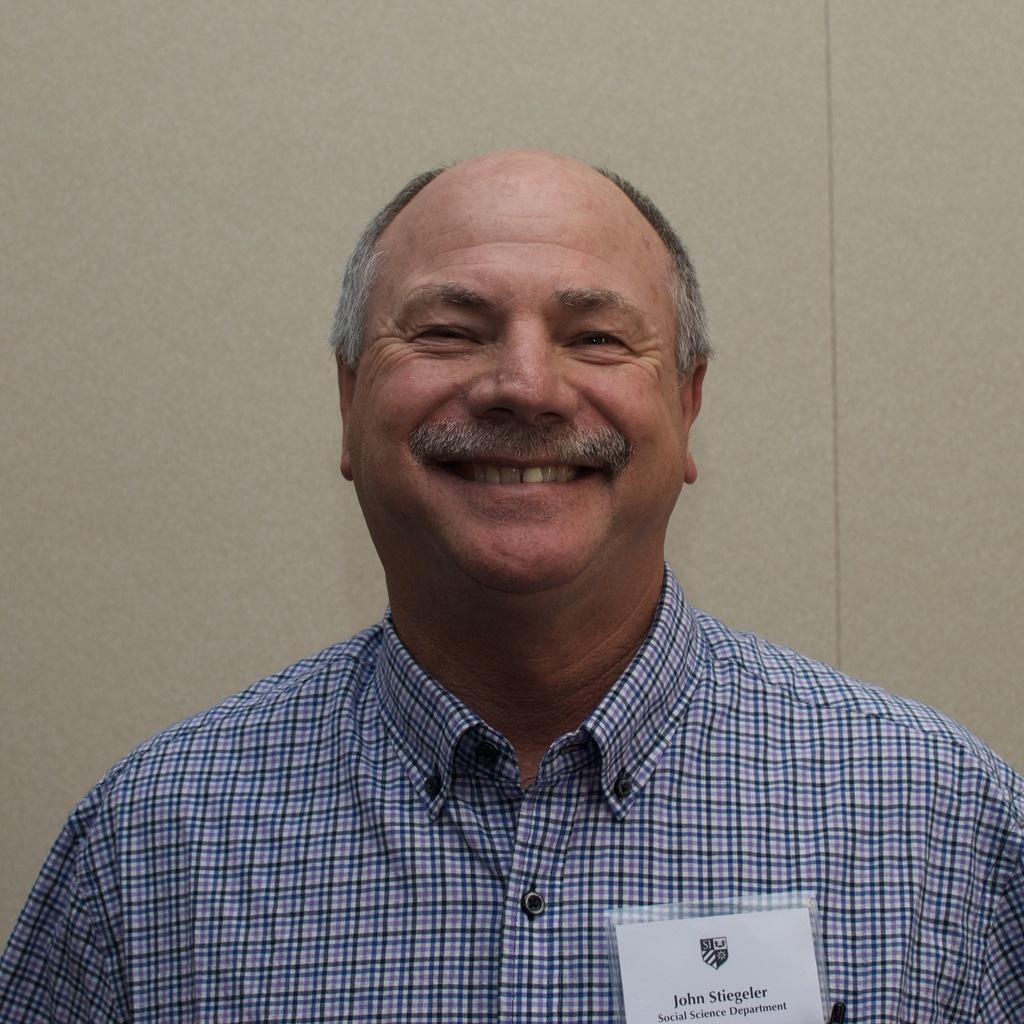Describe this image in one or two sentences. In this image, we can see an old man is watching and smiling. He wore a shirt. Here there is a batch. Background there is a wall. 